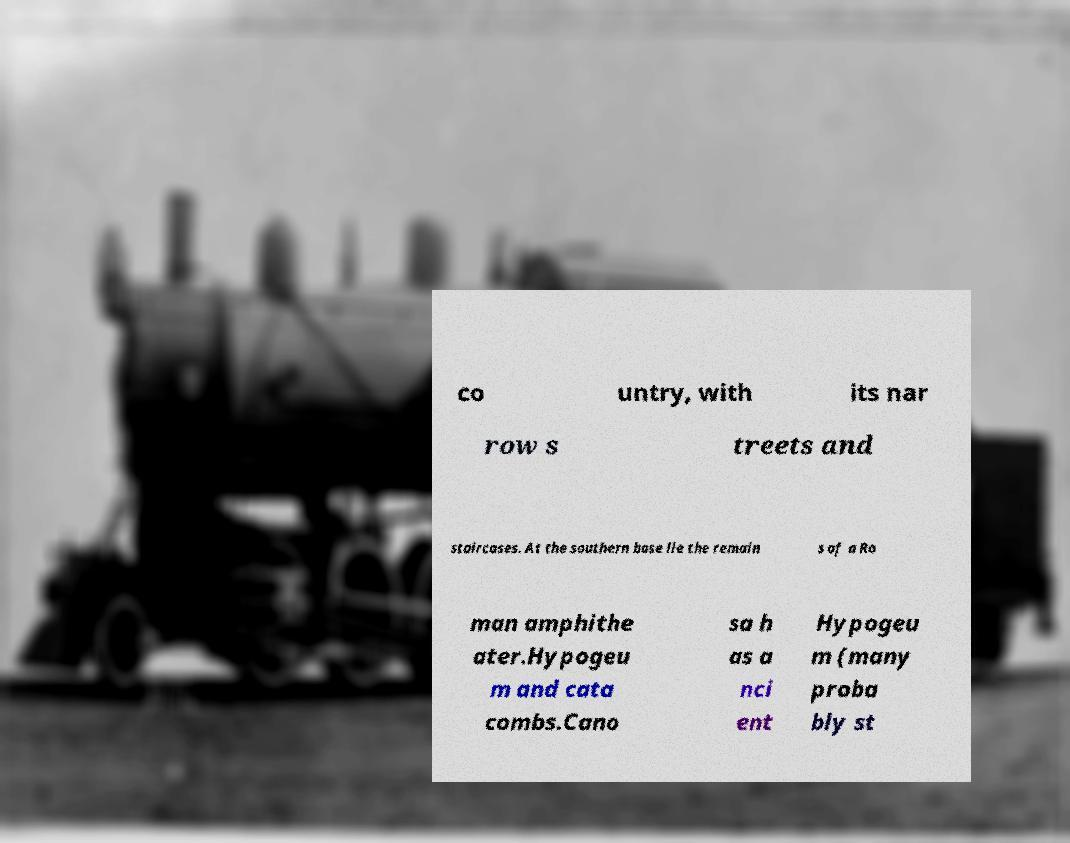Could you assist in decoding the text presented in this image and type it out clearly? co untry, with its nar row s treets and staircases. At the southern base lie the remain s of a Ro man amphithe ater.Hypogeu m and cata combs.Cano sa h as a nci ent Hypogeu m (many proba bly st 